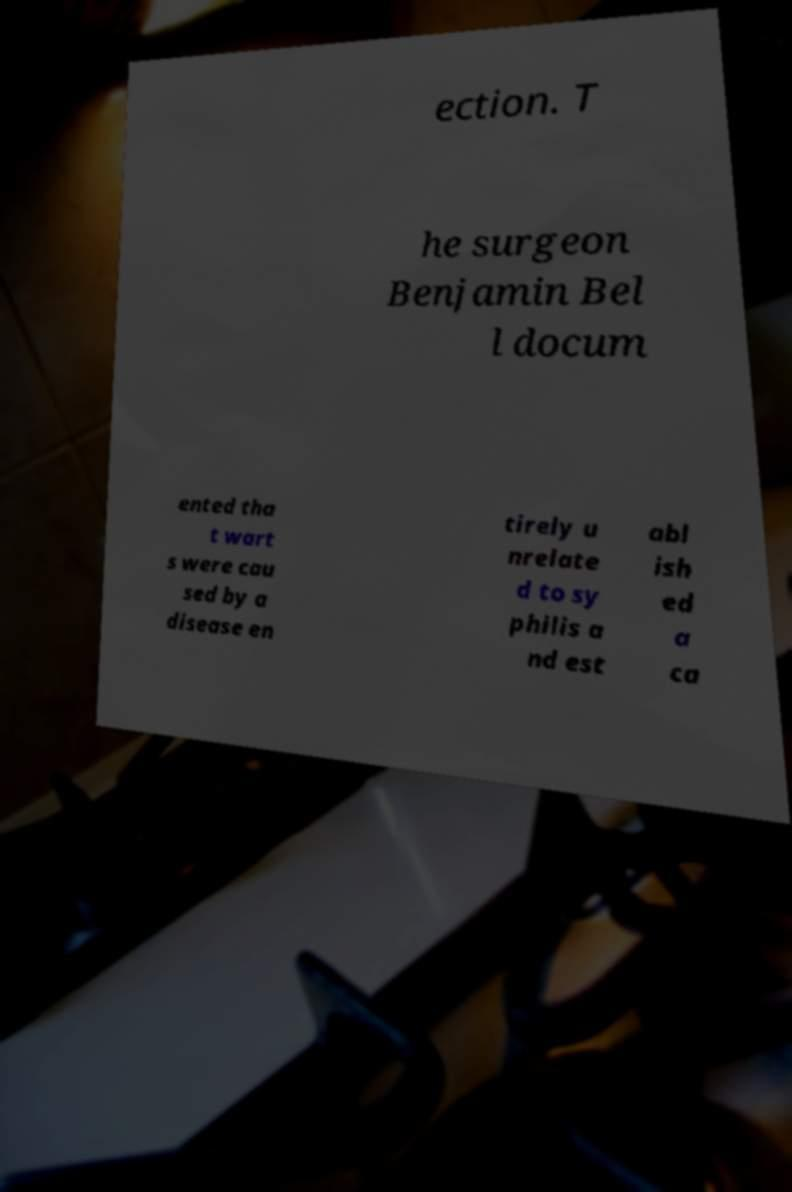For documentation purposes, I need the text within this image transcribed. Could you provide that? ection. T he surgeon Benjamin Bel l docum ented tha t wart s were cau sed by a disease en tirely u nrelate d to sy philis a nd est abl ish ed a ca 